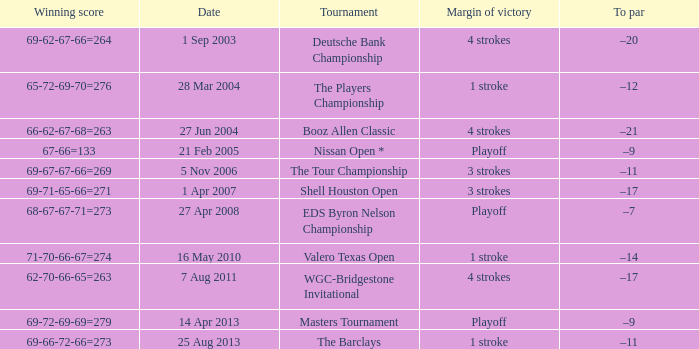Which date has a To par of –12? 28 Mar 2004. 